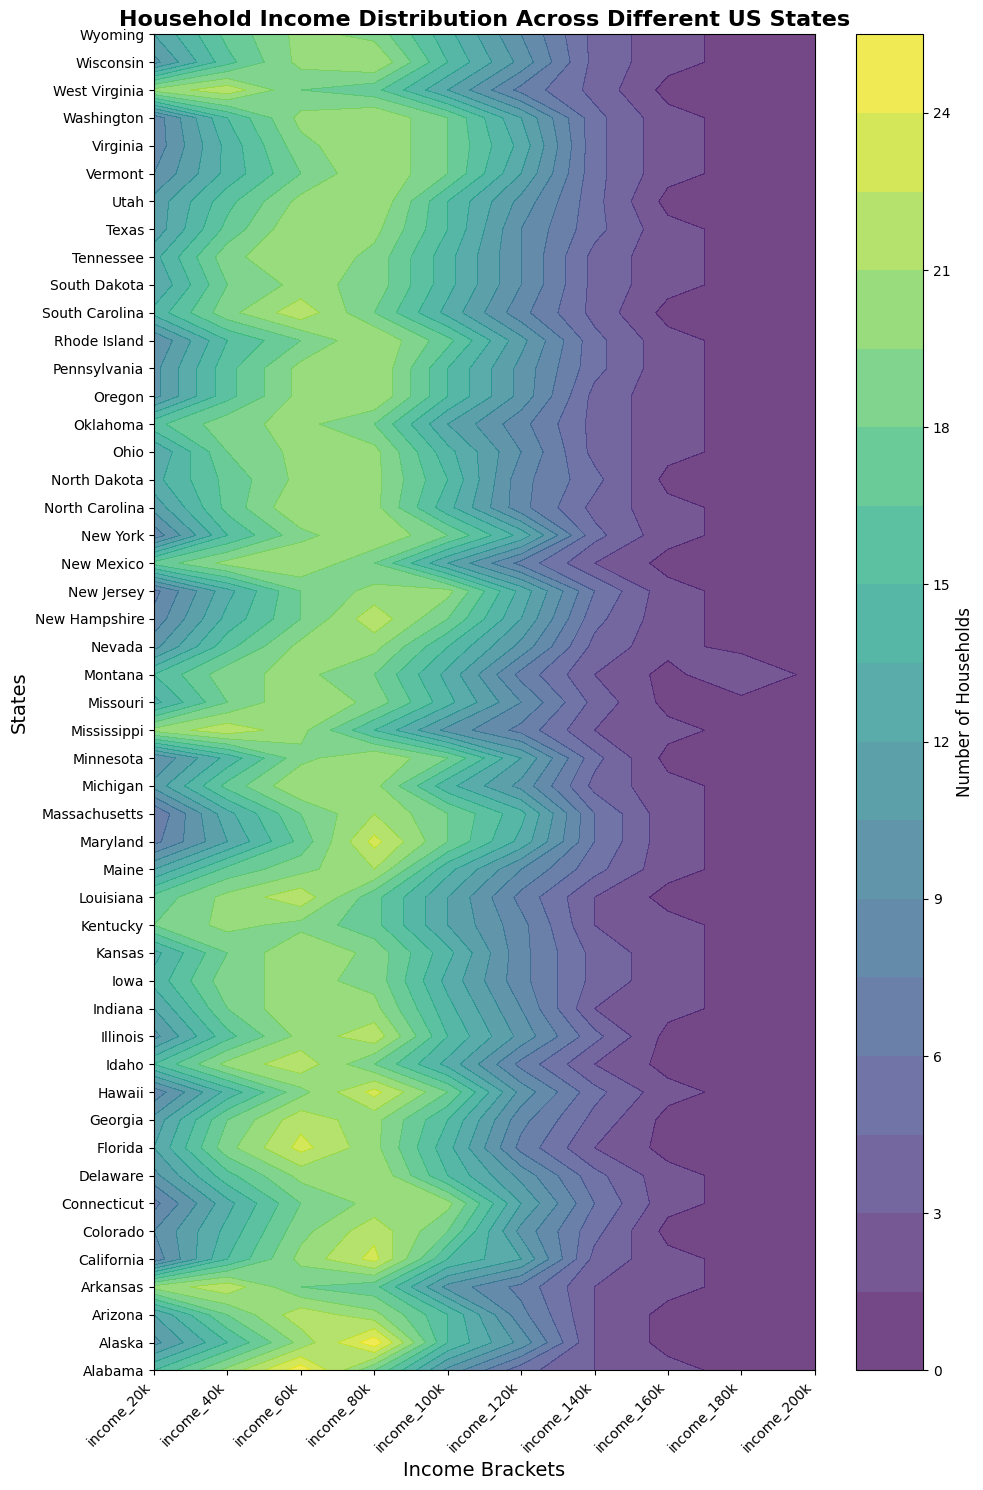Which state has the highest percentage of households with income in the $20k bracket? By examining the first column of color intensities for each state, we observe that the darkest shade, indicating the highest percentage, is found in Mississippi and West Virginia, which are the states with the highest percentage of households earning in the $20k bracket.
Answer: Mississippi, West Virginia How does the household distribution in the $60k income bracket in California compare with Texas? Look at the data values for the $60k income bracket and compare the contour heights at the position corresponding to California and Texas. California has a lighter color compared to Texas, meaning California has a higher percentage.
Answer: California > Texas What is the average number of households in the $100k income bracket across all states? Calculate the mean by adding the number of households for the $100k bracket in all states and then dividing by the number of states. After totaling the $100k bracket values from the dataset and dividing by 50 (the number of states), the calculation results in (10+15+15+10+15+18+20+...)/50 = 14.2.
Answer: 14.2 Which state shows the most even distribution across all income brackets? Examine the contour plot for states with the least variation in color intensity across all income brackets, indicating an even distribution. Iowa and Kansas show relatively even color distribution across the chart.
Answer: Iowa, Kansas Identify a state with a steep rise in households as income increases from $100k to $120k. Look for states where the color intensity sharply increases from the $100k to $120k bracket. States like Connecticut exhibit this characteristic.
Answer: Connecticut Between Alabama and Arkansas, which has a greater concentration of households in the $120k income bracket? Compare the contour lines or shades for the $120k income bracket for both states. Alabama has a lighter shade compared to Arkansas, indicating a lower concentration.
Answer: Arkansas What is the sum of households for all income brackets in Alaska? Add up the values of all income brackets for Alaska from the dataset. The sum is 10+15+20+25+15+10+3+1+0+1 = 100.
Answer: 100 Which income bracket shows the highest variance in household distribution across the states? Identify the column with the most variation in color intensities across rows. The $20k income bracket shows the highest variance with noticeable differences in color intensities across states.
Answer: $20k 